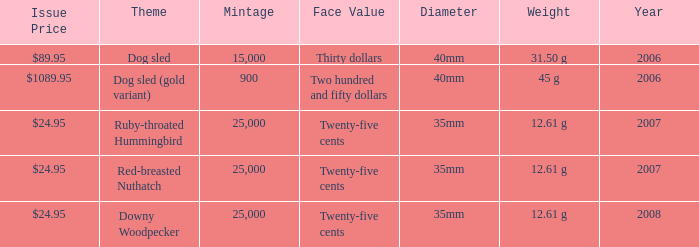What is the MIntage after 2006 of the Ruby-Throated Hummingbird Theme coin? 25000.0. 